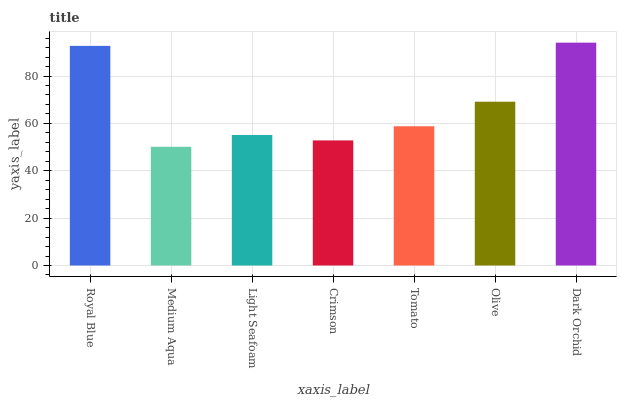Is Medium Aqua the minimum?
Answer yes or no. Yes. Is Dark Orchid the maximum?
Answer yes or no. Yes. Is Light Seafoam the minimum?
Answer yes or no. No. Is Light Seafoam the maximum?
Answer yes or no. No. Is Light Seafoam greater than Medium Aqua?
Answer yes or no. Yes. Is Medium Aqua less than Light Seafoam?
Answer yes or no. Yes. Is Medium Aqua greater than Light Seafoam?
Answer yes or no. No. Is Light Seafoam less than Medium Aqua?
Answer yes or no. No. Is Tomato the high median?
Answer yes or no. Yes. Is Tomato the low median?
Answer yes or no. Yes. Is Dark Orchid the high median?
Answer yes or no. No. Is Crimson the low median?
Answer yes or no. No. 